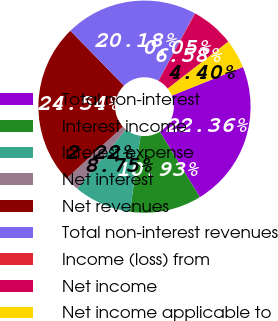Convert chart to OTSL. <chart><loc_0><loc_0><loc_500><loc_500><pie_chart><fcel>Total non-interest<fcel>Interest income<fcel>Interest expense<fcel>Net interest<fcel>Net revenues<fcel>Total non-interest revenues<fcel>Income (loss) from<fcel>Net income<fcel>Net income applicable to<nl><fcel>22.36%<fcel>10.93%<fcel>8.75%<fcel>2.22%<fcel>24.54%<fcel>20.18%<fcel>0.05%<fcel>6.58%<fcel>4.4%<nl></chart> 